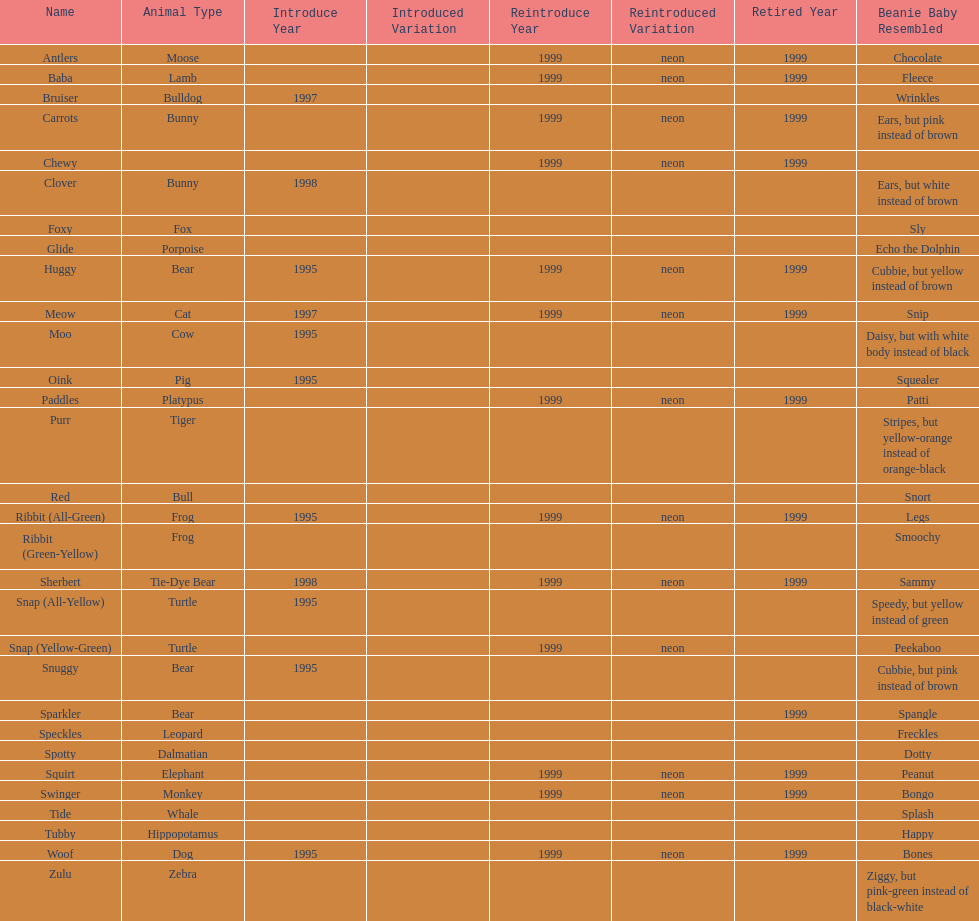What is the name of the last pillow pal on this chart? Zulu. 